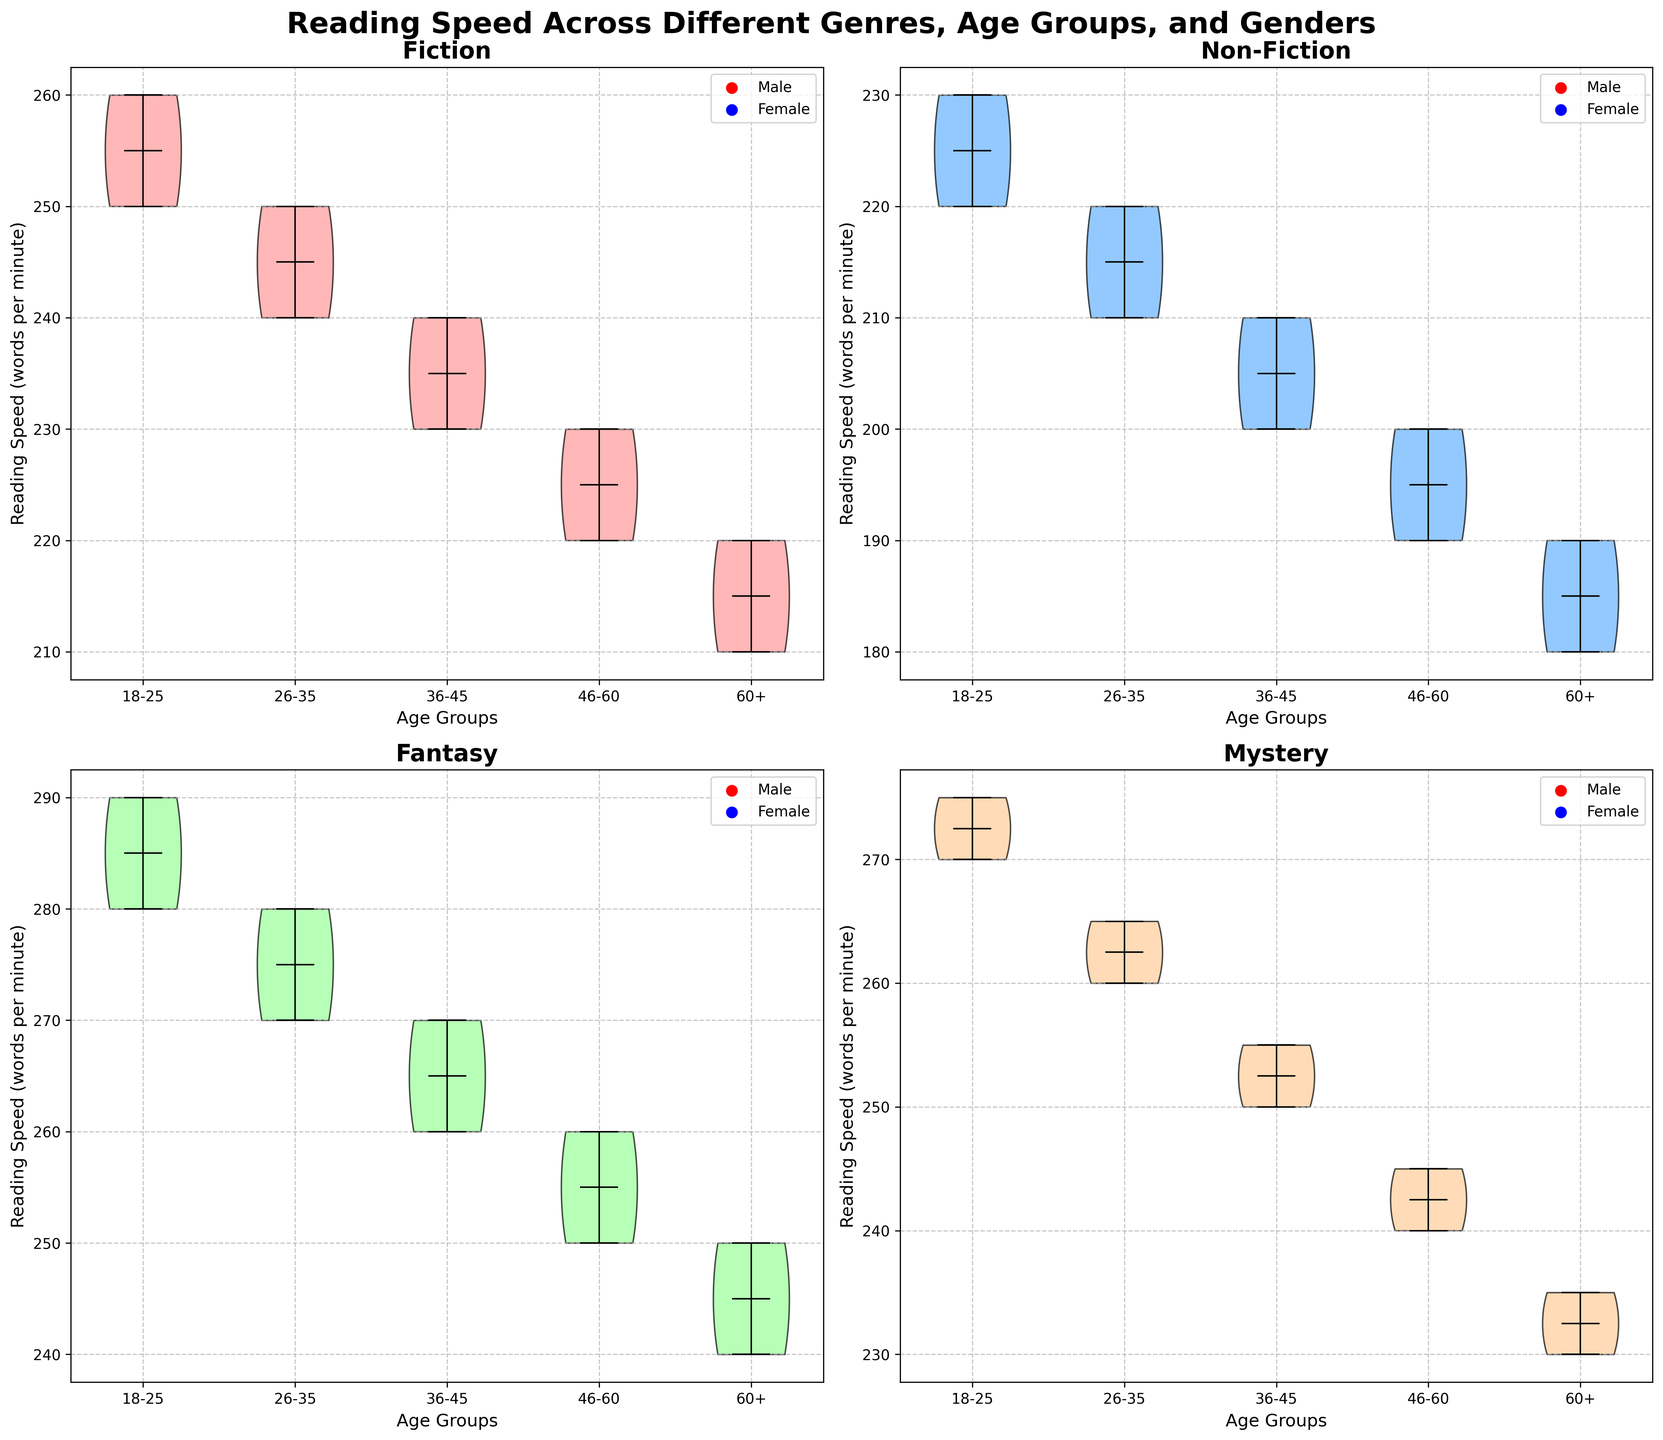Which genre shows the highest average reading speed for the 18-25 age group? Look at the 18-25 age group across all four genres in the subplots and compare the average read speeds. Fiction (250, 260), Non-Fiction (220, 230), Fantasy (280, 290), and Mystery (270, 275).
Answer: Fantasy How does the reading speed for males and females in the 46-60 age group compare for Mystery? Check the 46-60 age group in the Mystery subplot and compare the male and female reading speeds. Males read at 240 words per minute, females at 245 words per minute.
Answer: Females read slightly faster Which age group shows the largest difference in reading speed between males and females in Fiction? Look at the Fiction subplot and compare reading speeds between genders in each age group. For 18-25, the difference is 10; for 26-35, it is 10; for 36-45, it is 10; for 46-60, it is 10; and for 60+, it is 10. Each difference is 10.
Answer: All have the same difference What is the general trend of reading speeds across age groups for Non-Fiction? Observe the Non-Fiction subplot for males and females across all age groups and note the tendency. The speeds decrease progressively from 18-25 through 60+.
Answer: Decreasing trend How does the median reading speed of the 36-45 age group for Fantasy compare to the 60+ age group? Check the Fantasy subplot and compare the medians for 36-45 (260, 270) and 60+ (240, 250) age groups. The values decrease as age increases.
Answer: 36-45 is higher Which gender has the greater variation in reading speeds for Fantasy in the 18-25 age group? Look at the Fantasy subplot for the 18-25 age group and compare the spread for males (280) vs. females (290). Notice the distribution's width.
Answer: Females Is there any genre where the median reading speed remains the same across all age groups? Check the medians of each genre subplot for all age groups. Differences in medians are present in all genres.
Answer: No What can you infer about the median reading speed for males and females in the 26-35 age group for Fiction? Check the Fiction subplot for the 26-35 age group and compare median speeds for males (240) and females (250).
Answer: Females slightly higher In the genre Mystery, how does the reading speed change from age group 18-25 to 60+? Check the Mystery subplot, and observe the reading speed trend from 18-25 (270, 275) to 60+ (230, 235). The speeds decrease with increasing age.
Answer: Decreasing For Non-Fiction, which age group's median reading speed is closest between males and females? Observe the Non-Fiction subplot and compare the median reading speeds for all age groups. For 18-25, 220 vs 230; 26-35, 210 vs 220; 36-45, 200 vs 210; 46-60, 190 vs 200; 60+, 180 vs 190. Each group has a difference of 10.
Answer: Each group's median is equally distant 